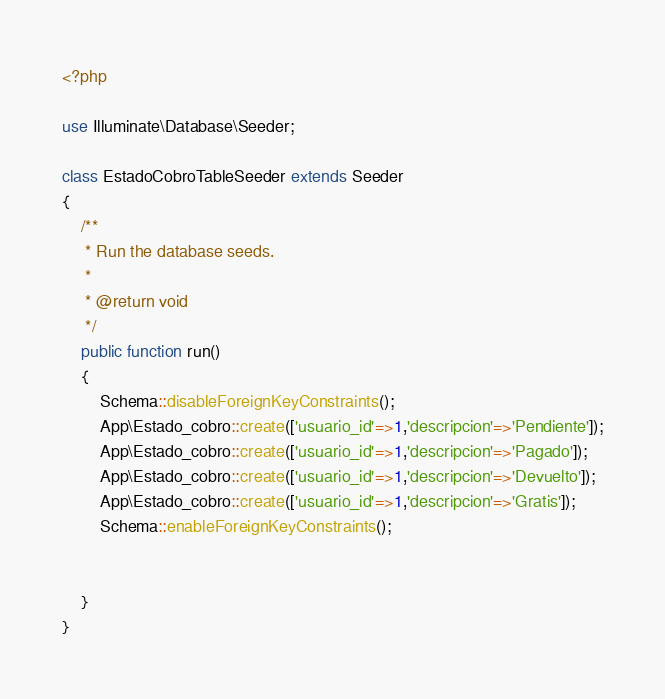<code> <loc_0><loc_0><loc_500><loc_500><_PHP_><?php

use Illuminate\Database\Seeder;

class EstadoCobroTableSeeder extends Seeder
{
    /**
     * Run the database seeds.
     *
     * @return void
     */
    public function run()
    {
        Schema::disableForeignKeyConstraints();
        App\Estado_cobro::create(['usuario_id'=>1,'descripcion'=>'Pendiente']);
        App\Estado_cobro::create(['usuario_id'=>1,'descripcion'=>'Pagado']);
        App\Estado_cobro::create(['usuario_id'=>1,'descripcion'=>'Devuelto']);
        App\Estado_cobro::create(['usuario_id'=>1,'descripcion'=>'Gratis']);
        Schema::enableForeignKeyConstraints();


    }
}
</code> 